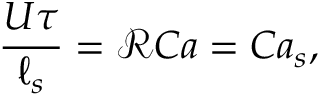Convert formula to latex. <formula><loc_0><loc_0><loc_500><loc_500>\frac { U \tau } { \ell _ { s } } = \mathcal { R } C a = C a _ { s } ,</formula> 